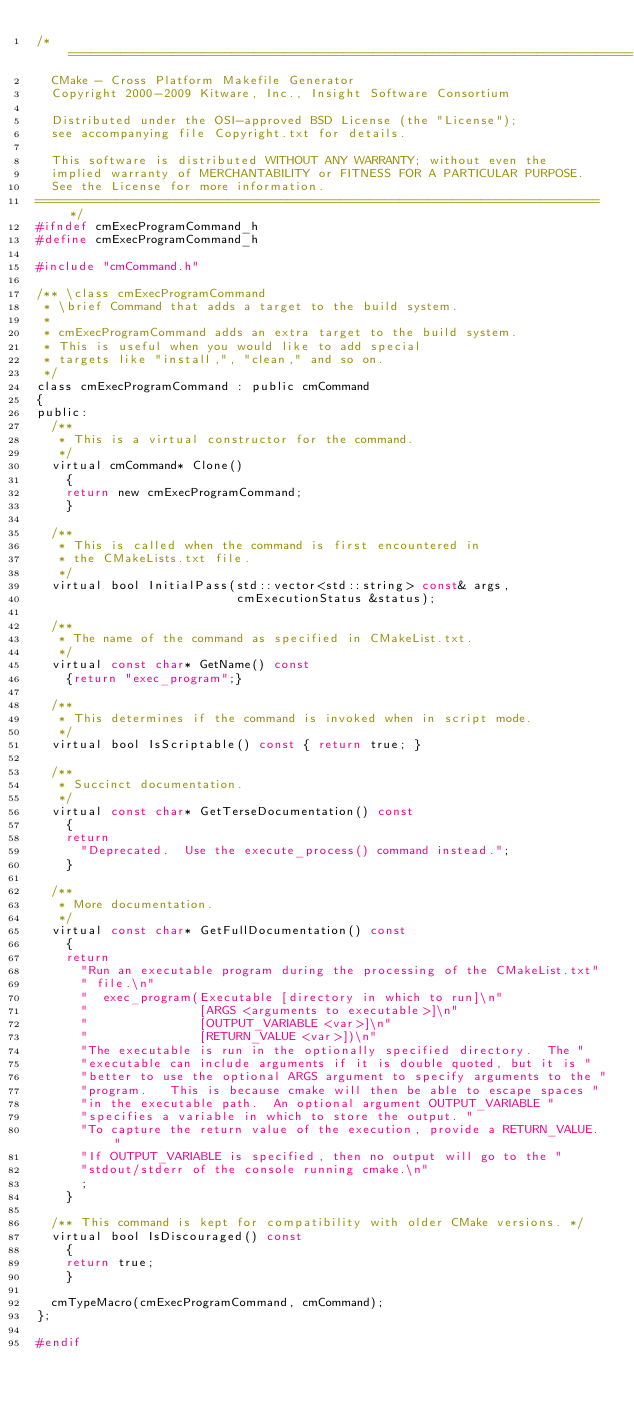<code> <loc_0><loc_0><loc_500><loc_500><_C_>/*============================================================================
  CMake - Cross Platform Makefile Generator
  Copyright 2000-2009 Kitware, Inc., Insight Software Consortium

  Distributed under the OSI-approved BSD License (the "License");
  see accompanying file Copyright.txt for details.

  This software is distributed WITHOUT ANY WARRANTY; without even the
  implied warranty of MERCHANTABILITY or FITNESS FOR A PARTICULAR PURPOSE.
  See the License for more information.
============================================================================*/
#ifndef cmExecProgramCommand_h
#define cmExecProgramCommand_h

#include "cmCommand.h"

/** \class cmExecProgramCommand
 * \brief Command that adds a target to the build system.
 *
 * cmExecProgramCommand adds an extra target to the build system.
 * This is useful when you would like to add special
 * targets like "install,", "clean," and so on.
 */
class cmExecProgramCommand : public cmCommand
{
public:
  /**
   * This is a virtual constructor for the command.
   */
  virtual cmCommand* Clone()
    {
    return new cmExecProgramCommand;
    }

  /**
   * This is called when the command is first encountered in
   * the CMakeLists.txt file.
   */
  virtual bool InitialPass(std::vector<std::string> const& args,
                           cmExecutionStatus &status);

  /**
   * The name of the command as specified in CMakeList.txt.
   */
  virtual const char* GetName() const
    {return "exec_program";}

  /**
   * This determines if the command is invoked when in script mode.
   */
  virtual bool IsScriptable() const { return true; }

  /**
   * Succinct documentation.
   */
  virtual const char* GetTerseDocumentation() const
    {
    return
      "Deprecated.  Use the execute_process() command instead.";
    }

  /**
   * More documentation.
   */
  virtual const char* GetFullDocumentation() const
    {
    return
      "Run an executable program during the processing of the CMakeList.txt"
      " file.\n"
      "  exec_program(Executable [directory in which to run]\n"
      "               [ARGS <arguments to executable>]\n"
      "               [OUTPUT_VARIABLE <var>]\n"
      "               [RETURN_VALUE <var>])\n"
      "The executable is run in the optionally specified directory.  The "
      "executable can include arguments if it is double quoted, but it is "
      "better to use the optional ARGS argument to specify arguments to the "
      "program.   This is because cmake will then be able to escape spaces "
      "in the executable path.  An optional argument OUTPUT_VARIABLE "
      "specifies a variable in which to store the output. "
      "To capture the return value of the execution, provide a RETURN_VALUE. "
      "If OUTPUT_VARIABLE is specified, then no output will go to the "
      "stdout/stderr of the console running cmake.\n"
      ;
    }

  /** This command is kept for compatibility with older CMake versions. */
  virtual bool IsDiscouraged() const
    {
    return true;
    }

  cmTypeMacro(cmExecProgramCommand, cmCommand);
};

#endif
</code> 